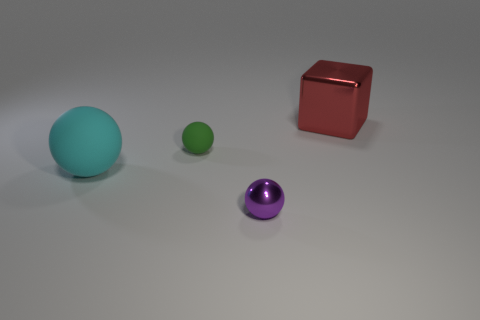Add 3 big blue cylinders. How many objects exist? 7 Subtract all spheres. How many objects are left? 1 Subtract 0 purple cubes. How many objects are left? 4 Subtract all small cyan metallic objects. Subtract all big rubber spheres. How many objects are left? 3 Add 2 small purple metal balls. How many small purple metal balls are left? 3 Add 2 small green matte things. How many small green matte things exist? 3 